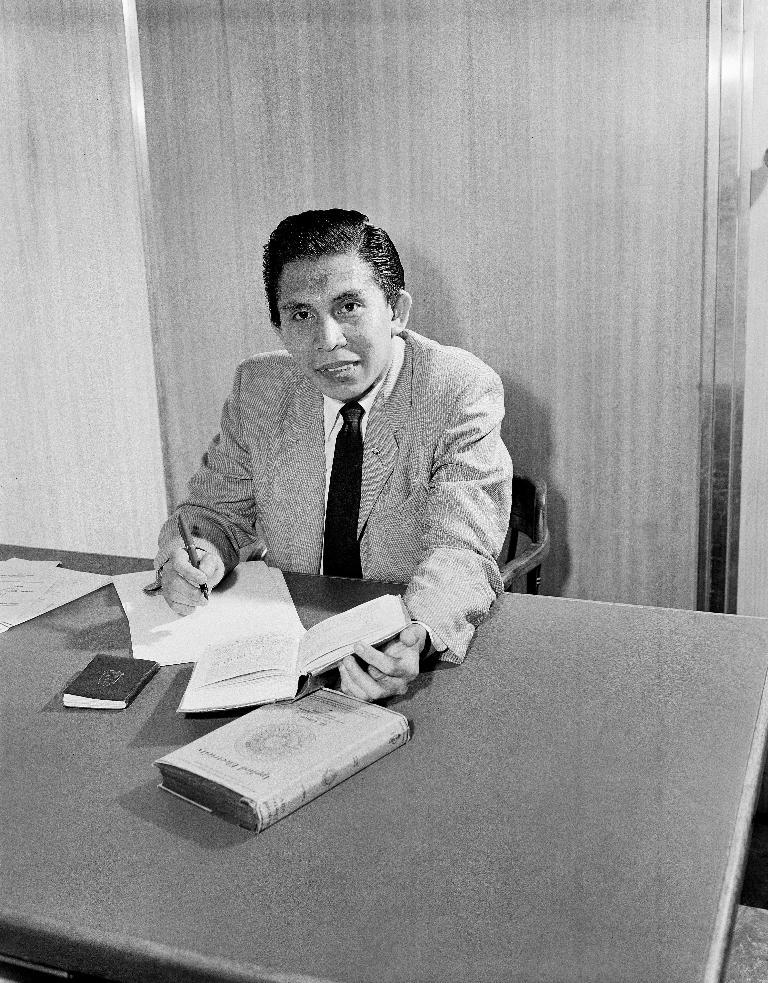What is the person in the image doing? The person is sitting on a chair in the image. What is in front of the person? There is a table in front of the person. What items can be seen on the table? There are books and papers on the table. What type of cub can be seen playing with the papers on the table? There is no cub present in the image, and therefore no such activity can be observed. 